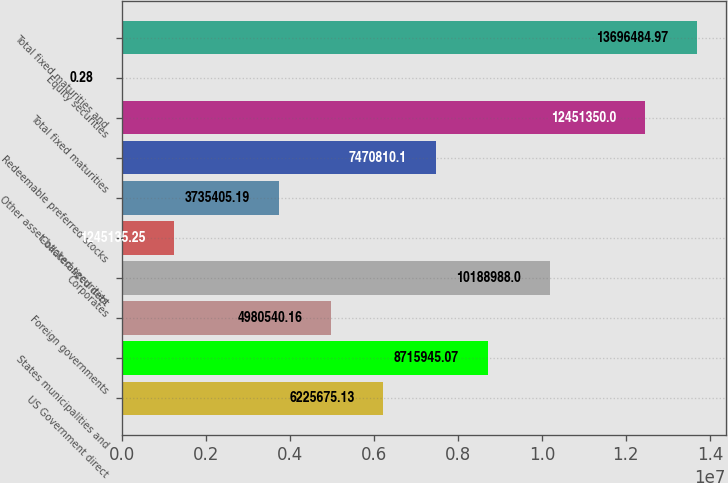Convert chart. <chart><loc_0><loc_0><loc_500><loc_500><bar_chart><fcel>US Government direct<fcel>States municipalities and<fcel>Foreign governments<fcel>Corporates<fcel>Collateralized debt<fcel>Other asset-backed securities<fcel>Redeemable preferred stocks<fcel>Total fixed maturities<fcel>Equity securities<fcel>Total fixed maturities and<nl><fcel>6.22568e+06<fcel>8.71595e+06<fcel>4.98054e+06<fcel>1.0189e+07<fcel>1.24514e+06<fcel>3.73541e+06<fcel>7.47081e+06<fcel>1.24514e+07<fcel>0.28<fcel>1.36965e+07<nl></chart> 